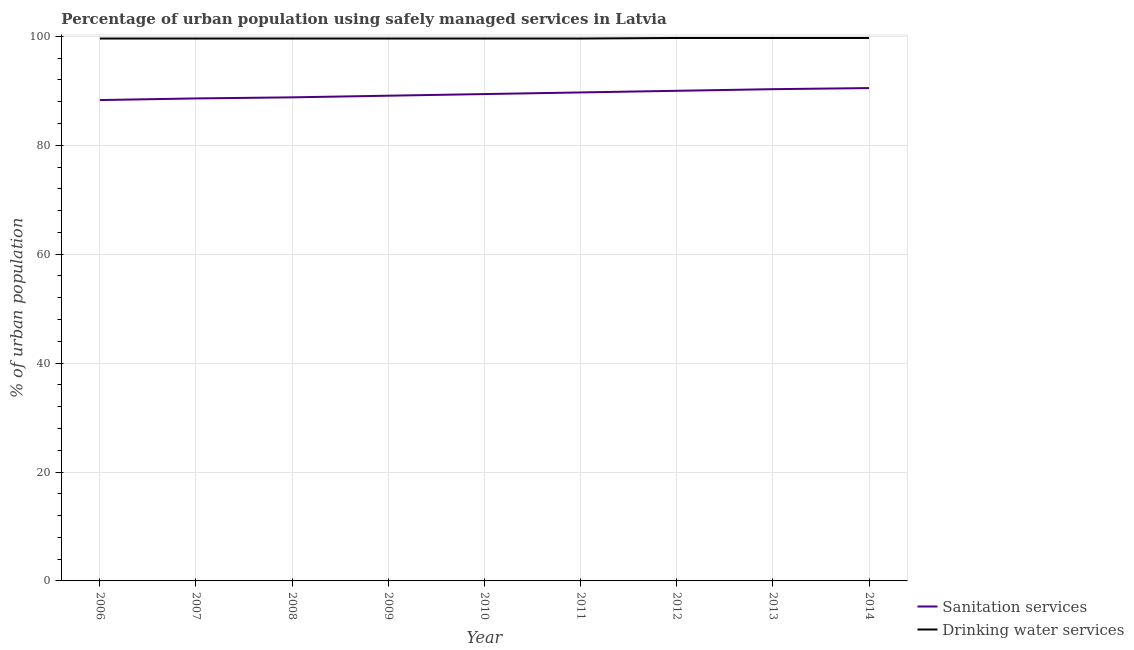Does the line corresponding to percentage of urban population who used drinking water services intersect with the line corresponding to percentage of urban population who used sanitation services?
Keep it short and to the point. No. Is the number of lines equal to the number of legend labels?
Provide a succinct answer. Yes. What is the percentage of urban population who used drinking water services in 2007?
Make the answer very short. 99.6. Across all years, what is the maximum percentage of urban population who used drinking water services?
Provide a succinct answer. 99.7. Across all years, what is the minimum percentage of urban population who used sanitation services?
Your answer should be compact. 88.3. In which year was the percentage of urban population who used sanitation services maximum?
Keep it short and to the point. 2014. In which year was the percentage of urban population who used drinking water services minimum?
Offer a very short reply. 2006. What is the total percentage of urban population who used drinking water services in the graph?
Offer a terse response. 896.7. What is the difference between the percentage of urban population who used drinking water services in 2014 and the percentage of urban population who used sanitation services in 2011?
Make the answer very short. 10. What is the average percentage of urban population who used drinking water services per year?
Offer a terse response. 99.63. In the year 2007, what is the difference between the percentage of urban population who used drinking water services and percentage of urban population who used sanitation services?
Provide a succinct answer. 11. What is the ratio of the percentage of urban population who used sanitation services in 2006 to that in 2013?
Provide a succinct answer. 0.98. Is the difference between the percentage of urban population who used drinking water services in 2006 and 2011 greater than the difference between the percentage of urban population who used sanitation services in 2006 and 2011?
Your answer should be compact. Yes. What is the difference between the highest and the second highest percentage of urban population who used sanitation services?
Give a very brief answer. 0.2. What is the difference between the highest and the lowest percentage of urban population who used drinking water services?
Keep it short and to the point. 0.1. In how many years, is the percentage of urban population who used sanitation services greater than the average percentage of urban population who used sanitation services taken over all years?
Offer a very short reply. 4. Is the sum of the percentage of urban population who used sanitation services in 2008 and 2013 greater than the maximum percentage of urban population who used drinking water services across all years?
Offer a very short reply. Yes. Does the percentage of urban population who used drinking water services monotonically increase over the years?
Offer a terse response. No. Is the percentage of urban population who used sanitation services strictly greater than the percentage of urban population who used drinking water services over the years?
Offer a terse response. No. How many years are there in the graph?
Keep it short and to the point. 9. What is the difference between two consecutive major ticks on the Y-axis?
Give a very brief answer. 20. Does the graph contain grids?
Give a very brief answer. Yes. Where does the legend appear in the graph?
Keep it short and to the point. Bottom right. How are the legend labels stacked?
Your answer should be compact. Vertical. What is the title of the graph?
Provide a short and direct response. Percentage of urban population using safely managed services in Latvia. What is the label or title of the Y-axis?
Offer a terse response. % of urban population. What is the % of urban population of Sanitation services in 2006?
Ensure brevity in your answer.  88.3. What is the % of urban population in Drinking water services in 2006?
Your answer should be very brief. 99.6. What is the % of urban population in Sanitation services in 2007?
Your answer should be compact. 88.6. What is the % of urban population of Drinking water services in 2007?
Make the answer very short. 99.6. What is the % of urban population in Sanitation services in 2008?
Give a very brief answer. 88.8. What is the % of urban population of Drinking water services in 2008?
Keep it short and to the point. 99.6. What is the % of urban population in Sanitation services in 2009?
Give a very brief answer. 89.1. What is the % of urban population of Drinking water services in 2009?
Keep it short and to the point. 99.6. What is the % of urban population in Sanitation services in 2010?
Give a very brief answer. 89.4. What is the % of urban population of Drinking water services in 2010?
Give a very brief answer. 99.6. What is the % of urban population of Sanitation services in 2011?
Keep it short and to the point. 89.7. What is the % of urban population in Drinking water services in 2011?
Provide a succinct answer. 99.6. What is the % of urban population of Drinking water services in 2012?
Your answer should be compact. 99.7. What is the % of urban population in Sanitation services in 2013?
Your response must be concise. 90.3. What is the % of urban population in Drinking water services in 2013?
Your answer should be very brief. 99.7. What is the % of urban population in Sanitation services in 2014?
Provide a succinct answer. 90.5. What is the % of urban population in Drinking water services in 2014?
Give a very brief answer. 99.7. Across all years, what is the maximum % of urban population in Sanitation services?
Give a very brief answer. 90.5. Across all years, what is the maximum % of urban population in Drinking water services?
Your response must be concise. 99.7. Across all years, what is the minimum % of urban population of Sanitation services?
Provide a succinct answer. 88.3. Across all years, what is the minimum % of urban population of Drinking water services?
Make the answer very short. 99.6. What is the total % of urban population of Sanitation services in the graph?
Your answer should be very brief. 804.7. What is the total % of urban population of Drinking water services in the graph?
Provide a short and direct response. 896.7. What is the difference between the % of urban population in Sanitation services in 2006 and that in 2007?
Keep it short and to the point. -0.3. What is the difference between the % of urban population in Drinking water services in 2006 and that in 2008?
Your answer should be very brief. 0. What is the difference between the % of urban population in Sanitation services in 2006 and that in 2011?
Give a very brief answer. -1.4. What is the difference between the % of urban population of Sanitation services in 2006 and that in 2012?
Make the answer very short. -1.7. What is the difference between the % of urban population in Sanitation services in 2006 and that in 2013?
Provide a short and direct response. -2. What is the difference between the % of urban population of Drinking water services in 2006 and that in 2013?
Keep it short and to the point. -0.1. What is the difference between the % of urban population of Sanitation services in 2006 and that in 2014?
Provide a short and direct response. -2.2. What is the difference between the % of urban population of Sanitation services in 2007 and that in 2008?
Offer a very short reply. -0.2. What is the difference between the % of urban population of Drinking water services in 2007 and that in 2009?
Provide a succinct answer. 0. What is the difference between the % of urban population of Sanitation services in 2007 and that in 2010?
Provide a succinct answer. -0.8. What is the difference between the % of urban population of Drinking water services in 2007 and that in 2011?
Your answer should be compact. 0. What is the difference between the % of urban population in Drinking water services in 2007 and that in 2012?
Your response must be concise. -0.1. What is the difference between the % of urban population in Drinking water services in 2007 and that in 2013?
Your answer should be very brief. -0.1. What is the difference between the % of urban population in Sanitation services in 2007 and that in 2014?
Keep it short and to the point. -1.9. What is the difference between the % of urban population in Sanitation services in 2008 and that in 2009?
Offer a very short reply. -0.3. What is the difference between the % of urban population in Drinking water services in 2008 and that in 2009?
Offer a very short reply. 0. What is the difference between the % of urban population in Sanitation services in 2008 and that in 2010?
Make the answer very short. -0.6. What is the difference between the % of urban population in Sanitation services in 2008 and that in 2012?
Provide a short and direct response. -1.2. What is the difference between the % of urban population of Drinking water services in 2008 and that in 2012?
Ensure brevity in your answer.  -0.1. What is the difference between the % of urban population of Sanitation services in 2008 and that in 2013?
Ensure brevity in your answer.  -1.5. What is the difference between the % of urban population of Sanitation services in 2008 and that in 2014?
Offer a very short reply. -1.7. What is the difference between the % of urban population in Drinking water services in 2008 and that in 2014?
Offer a very short reply. -0.1. What is the difference between the % of urban population in Sanitation services in 2009 and that in 2011?
Your response must be concise. -0.6. What is the difference between the % of urban population of Sanitation services in 2009 and that in 2012?
Your answer should be compact. -0.9. What is the difference between the % of urban population of Drinking water services in 2009 and that in 2012?
Make the answer very short. -0.1. What is the difference between the % of urban population of Drinking water services in 2009 and that in 2013?
Provide a short and direct response. -0.1. What is the difference between the % of urban population of Drinking water services in 2009 and that in 2014?
Make the answer very short. -0.1. What is the difference between the % of urban population of Sanitation services in 2010 and that in 2012?
Give a very brief answer. -0.6. What is the difference between the % of urban population of Sanitation services in 2010 and that in 2013?
Your answer should be very brief. -0.9. What is the difference between the % of urban population of Drinking water services in 2010 and that in 2013?
Give a very brief answer. -0.1. What is the difference between the % of urban population of Sanitation services in 2010 and that in 2014?
Provide a succinct answer. -1.1. What is the difference between the % of urban population in Sanitation services in 2011 and that in 2012?
Offer a terse response. -0.3. What is the difference between the % of urban population of Drinking water services in 2011 and that in 2012?
Give a very brief answer. -0.1. What is the difference between the % of urban population of Sanitation services in 2011 and that in 2014?
Provide a short and direct response. -0.8. What is the difference between the % of urban population in Drinking water services in 2011 and that in 2014?
Your answer should be very brief. -0.1. What is the difference between the % of urban population of Sanitation services in 2012 and that in 2013?
Give a very brief answer. -0.3. What is the difference between the % of urban population in Sanitation services in 2013 and that in 2014?
Your answer should be compact. -0.2. What is the difference between the % of urban population of Sanitation services in 2006 and the % of urban population of Drinking water services in 2008?
Your answer should be very brief. -11.3. What is the difference between the % of urban population in Sanitation services in 2006 and the % of urban population in Drinking water services in 2009?
Offer a very short reply. -11.3. What is the difference between the % of urban population of Sanitation services in 2006 and the % of urban population of Drinking water services in 2010?
Offer a terse response. -11.3. What is the difference between the % of urban population of Sanitation services in 2006 and the % of urban population of Drinking water services in 2012?
Your answer should be compact. -11.4. What is the difference between the % of urban population of Sanitation services in 2006 and the % of urban population of Drinking water services in 2013?
Provide a succinct answer. -11.4. What is the difference between the % of urban population of Sanitation services in 2007 and the % of urban population of Drinking water services in 2010?
Your answer should be compact. -11. What is the difference between the % of urban population of Sanitation services in 2007 and the % of urban population of Drinking water services in 2013?
Keep it short and to the point. -11.1. What is the difference between the % of urban population of Sanitation services in 2008 and the % of urban population of Drinking water services in 2010?
Your answer should be very brief. -10.8. What is the difference between the % of urban population of Sanitation services in 2008 and the % of urban population of Drinking water services in 2011?
Offer a very short reply. -10.8. What is the difference between the % of urban population of Sanitation services in 2008 and the % of urban population of Drinking water services in 2014?
Keep it short and to the point. -10.9. What is the difference between the % of urban population of Sanitation services in 2009 and the % of urban population of Drinking water services in 2010?
Make the answer very short. -10.5. What is the difference between the % of urban population in Sanitation services in 2010 and the % of urban population in Drinking water services in 2014?
Offer a terse response. -10.3. What is the difference between the % of urban population in Sanitation services in 2011 and the % of urban population in Drinking water services in 2012?
Provide a short and direct response. -10. What is the difference between the % of urban population of Sanitation services in 2011 and the % of urban population of Drinking water services in 2013?
Your response must be concise. -10. What is the difference between the % of urban population of Sanitation services in 2011 and the % of urban population of Drinking water services in 2014?
Keep it short and to the point. -10. What is the difference between the % of urban population in Sanitation services in 2013 and the % of urban population in Drinking water services in 2014?
Keep it short and to the point. -9.4. What is the average % of urban population in Sanitation services per year?
Ensure brevity in your answer.  89.41. What is the average % of urban population in Drinking water services per year?
Make the answer very short. 99.63. In the year 2009, what is the difference between the % of urban population of Sanitation services and % of urban population of Drinking water services?
Offer a terse response. -10.5. In the year 2010, what is the difference between the % of urban population in Sanitation services and % of urban population in Drinking water services?
Provide a short and direct response. -10.2. In the year 2011, what is the difference between the % of urban population in Sanitation services and % of urban population in Drinking water services?
Keep it short and to the point. -9.9. What is the ratio of the % of urban population of Drinking water services in 2006 to that in 2009?
Offer a very short reply. 1. What is the ratio of the % of urban population of Sanitation services in 2006 to that in 2010?
Give a very brief answer. 0.99. What is the ratio of the % of urban population in Drinking water services in 2006 to that in 2010?
Ensure brevity in your answer.  1. What is the ratio of the % of urban population in Sanitation services in 2006 to that in 2011?
Provide a short and direct response. 0.98. What is the ratio of the % of urban population of Drinking water services in 2006 to that in 2011?
Your answer should be very brief. 1. What is the ratio of the % of urban population in Sanitation services in 2006 to that in 2012?
Provide a succinct answer. 0.98. What is the ratio of the % of urban population in Sanitation services in 2006 to that in 2013?
Provide a short and direct response. 0.98. What is the ratio of the % of urban population of Drinking water services in 2006 to that in 2013?
Provide a succinct answer. 1. What is the ratio of the % of urban population in Sanitation services in 2006 to that in 2014?
Offer a very short reply. 0.98. What is the ratio of the % of urban population of Drinking water services in 2006 to that in 2014?
Give a very brief answer. 1. What is the ratio of the % of urban population of Sanitation services in 2007 to that in 2009?
Ensure brevity in your answer.  0.99. What is the ratio of the % of urban population in Drinking water services in 2007 to that in 2009?
Provide a succinct answer. 1. What is the ratio of the % of urban population of Sanitation services in 2007 to that in 2010?
Your answer should be very brief. 0.99. What is the ratio of the % of urban population in Drinking water services in 2007 to that in 2010?
Ensure brevity in your answer.  1. What is the ratio of the % of urban population in Sanitation services in 2007 to that in 2012?
Offer a terse response. 0.98. What is the ratio of the % of urban population in Sanitation services in 2007 to that in 2013?
Ensure brevity in your answer.  0.98. What is the ratio of the % of urban population in Sanitation services in 2007 to that in 2014?
Keep it short and to the point. 0.98. What is the ratio of the % of urban population of Drinking water services in 2008 to that in 2009?
Your answer should be compact. 1. What is the ratio of the % of urban population in Sanitation services in 2008 to that in 2010?
Give a very brief answer. 0.99. What is the ratio of the % of urban population of Sanitation services in 2008 to that in 2011?
Make the answer very short. 0.99. What is the ratio of the % of urban population in Drinking water services in 2008 to that in 2011?
Provide a succinct answer. 1. What is the ratio of the % of urban population of Sanitation services in 2008 to that in 2012?
Your response must be concise. 0.99. What is the ratio of the % of urban population in Drinking water services in 2008 to that in 2012?
Make the answer very short. 1. What is the ratio of the % of urban population of Sanitation services in 2008 to that in 2013?
Your response must be concise. 0.98. What is the ratio of the % of urban population of Sanitation services in 2008 to that in 2014?
Your answer should be compact. 0.98. What is the ratio of the % of urban population in Drinking water services in 2008 to that in 2014?
Provide a succinct answer. 1. What is the ratio of the % of urban population of Drinking water services in 2009 to that in 2010?
Give a very brief answer. 1. What is the ratio of the % of urban population of Drinking water services in 2009 to that in 2011?
Provide a succinct answer. 1. What is the ratio of the % of urban population in Drinking water services in 2009 to that in 2012?
Make the answer very short. 1. What is the ratio of the % of urban population of Sanitation services in 2009 to that in 2013?
Provide a succinct answer. 0.99. What is the ratio of the % of urban population in Sanitation services in 2009 to that in 2014?
Keep it short and to the point. 0.98. What is the ratio of the % of urban population in Sanitation services in 2010 to that in 2011?
Give a very brief answer. 1. What is the ratio of the % of urban population in Drinking water services in 2010 to that in 2011?
Provide a succinct answer. 1. What is the ratio of the % of urban population of Sanitation services in 2010 to that in 2012?
Make the answer very short. 0.99. What is the ratio of the % of urban population in Drinking water services in 2010 to that in 2012?
Your answer should be compact. 1. What is the ratio of the % of urban population of Drinking water services in 2010 to that in 2013?
Make the answer very short. 1. What is the ratio of the % of urban population of Sanitation services in 2010 to that in 2014?
Your answer should be compact. 0.99. What is the ratio of the % of urban population of Drinking water services in 2010 to that in 2014?
Provide a succinct answer. 1. What is the ratio of the % of urban population of Sanitation services in 2011 to that in 2012?
Give a very brief answer. 1. What is the ratio of the % of urban population in Sanitation services in 2011 to that in 2013?
Offer a terse response. 0.99. What is the ratio of the % of urban population of Drinking water services in 2011 to that in 2014?
Offer a very short reply. 1. What is the ratio of the % of urban population of Drinking water services in 2012 to that in 2013?
Keep it short and to the point. 1. What is the ratio of the % of urban population in Sanitation services in 2012 to that in 2014?
Offer a very short reply. 0.99. What is the ratio of the % of urban population in Drinking water services in 2012 to that in 2014?
Offer a terse response. 1. What is the ratio of the % of urban population of Drinking water services in 2013 to that in 2014?
Offer a very short reply. 1. What is the difference between the highest and the lowest % of urban population in Sanitation services?
Your answer should be very brief. 2.2. What is the difference between the highest and the lowest % of urban population of Drinking water services?
Make the answer very short. 0.1. 